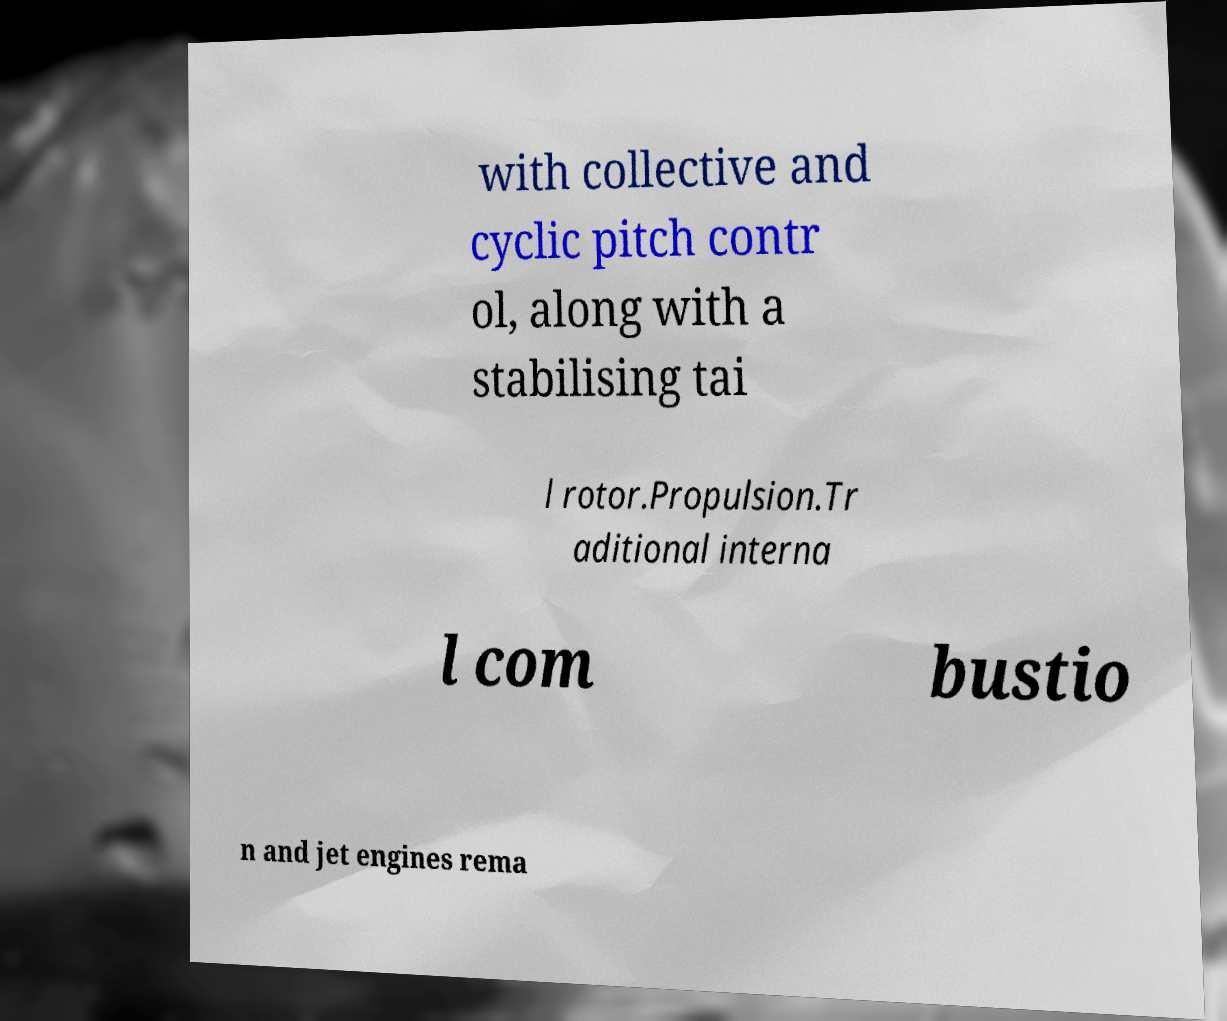I need the written content from this picture converted into text. Can you do that? with collective and cyclic pitch contr ol, along with a stabilising tai l rotor.Propulsion.Tr aditional interna l com bustio n and jet engines rema 